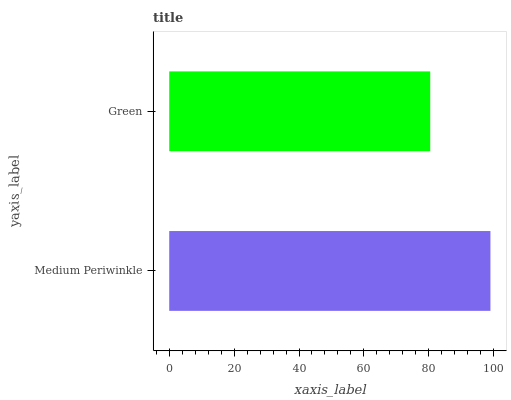Is Green the minimum?
Answer yes or no. Yes. Is Medium Periwinkle the maximum?
Answer yes or no. Yes. Is Green the maximum?
Answer yes or no. No. Is Medium Periwinkle greater than Green?
Answer yes or no. Yes. Is Green less than Medium Periwinkle?
Answer yes or no. Yes. Is Green greater than Medium Periwinkle?
Answer yes or no. No. Is Medium Periwinkle less than Green?
Answer yes or no. No. Is Medium Periwinkle the high median?
Answer yes or no. Yes. Is Green the low median?
Answer yes or no. Yes. Is Green the high median?
Answer yes or no. No. Is Medium Periwinkle the low median?
Answer yes or no. No. 